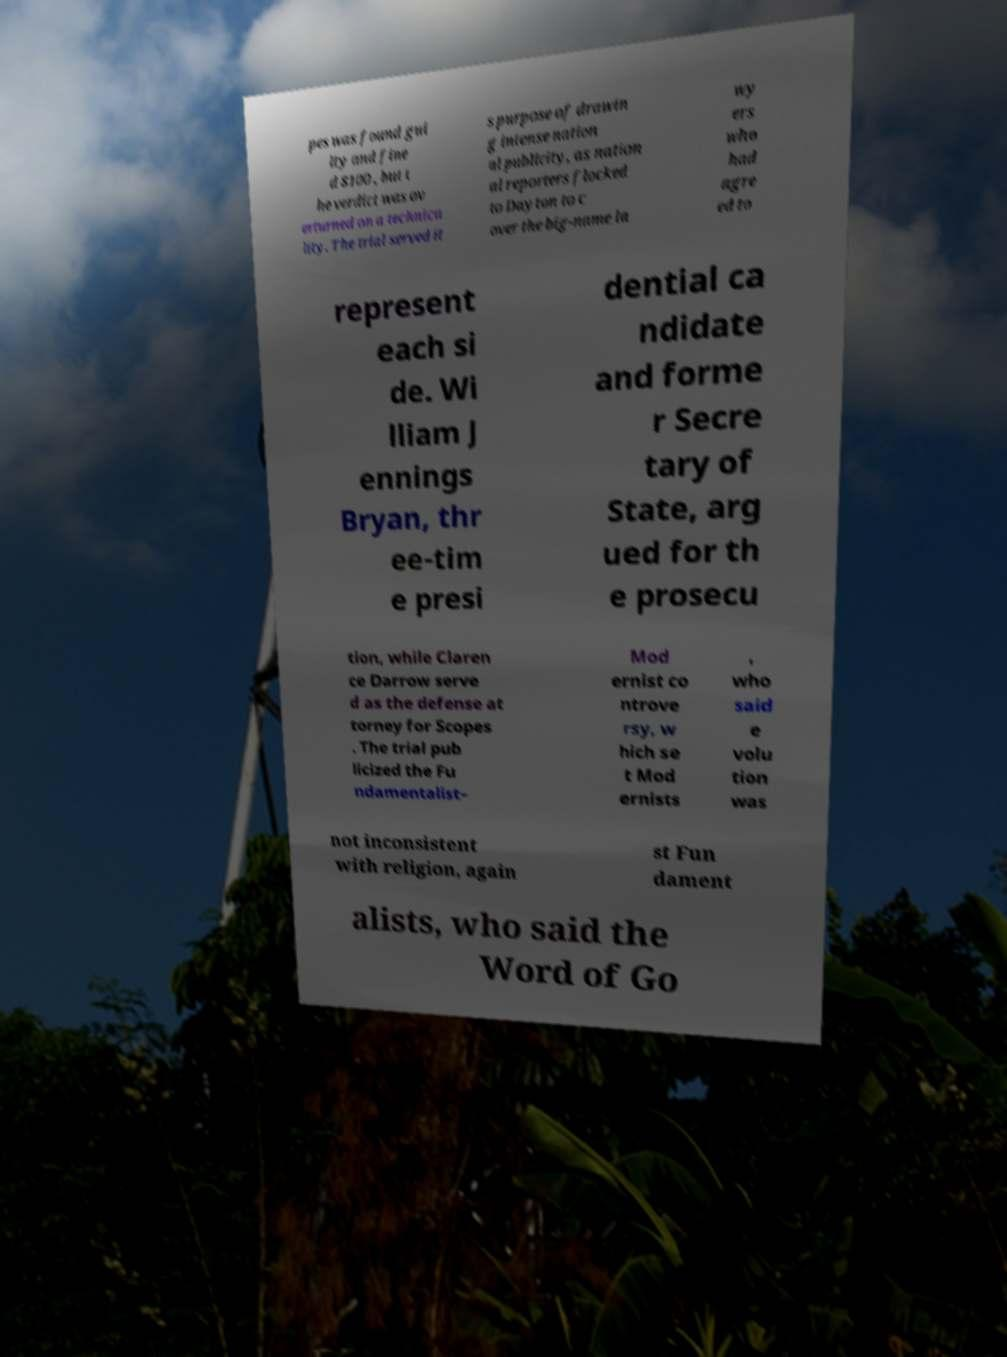What messages or text are displayed in this image? I need them in a readable, typed format. pes was found gui lty and fine d $100 , but t he verdict was ov erturned on a technica lity. The trial served it s purpose of drawin g intense nation al publicity, as nation al reporters flocked to Dayton to c over the big-name la wy ers who had agre ed to represent each si de. Wi lliam J ennings Bryan, thr ee-tim e presi dential ca ndidate and forme r Secre tary of State, arg ued for th e prosecu tion, while Claren ce Darrow serve d as the defense at torney for Scopes . The trial pub licized the Fu ndamentalist– Mod ernist co ntrove rsy, w hich se t Mod ernists , who said e volu tion was not inconsistent with religion, again st Fun dament alists, who said the Word of Go 